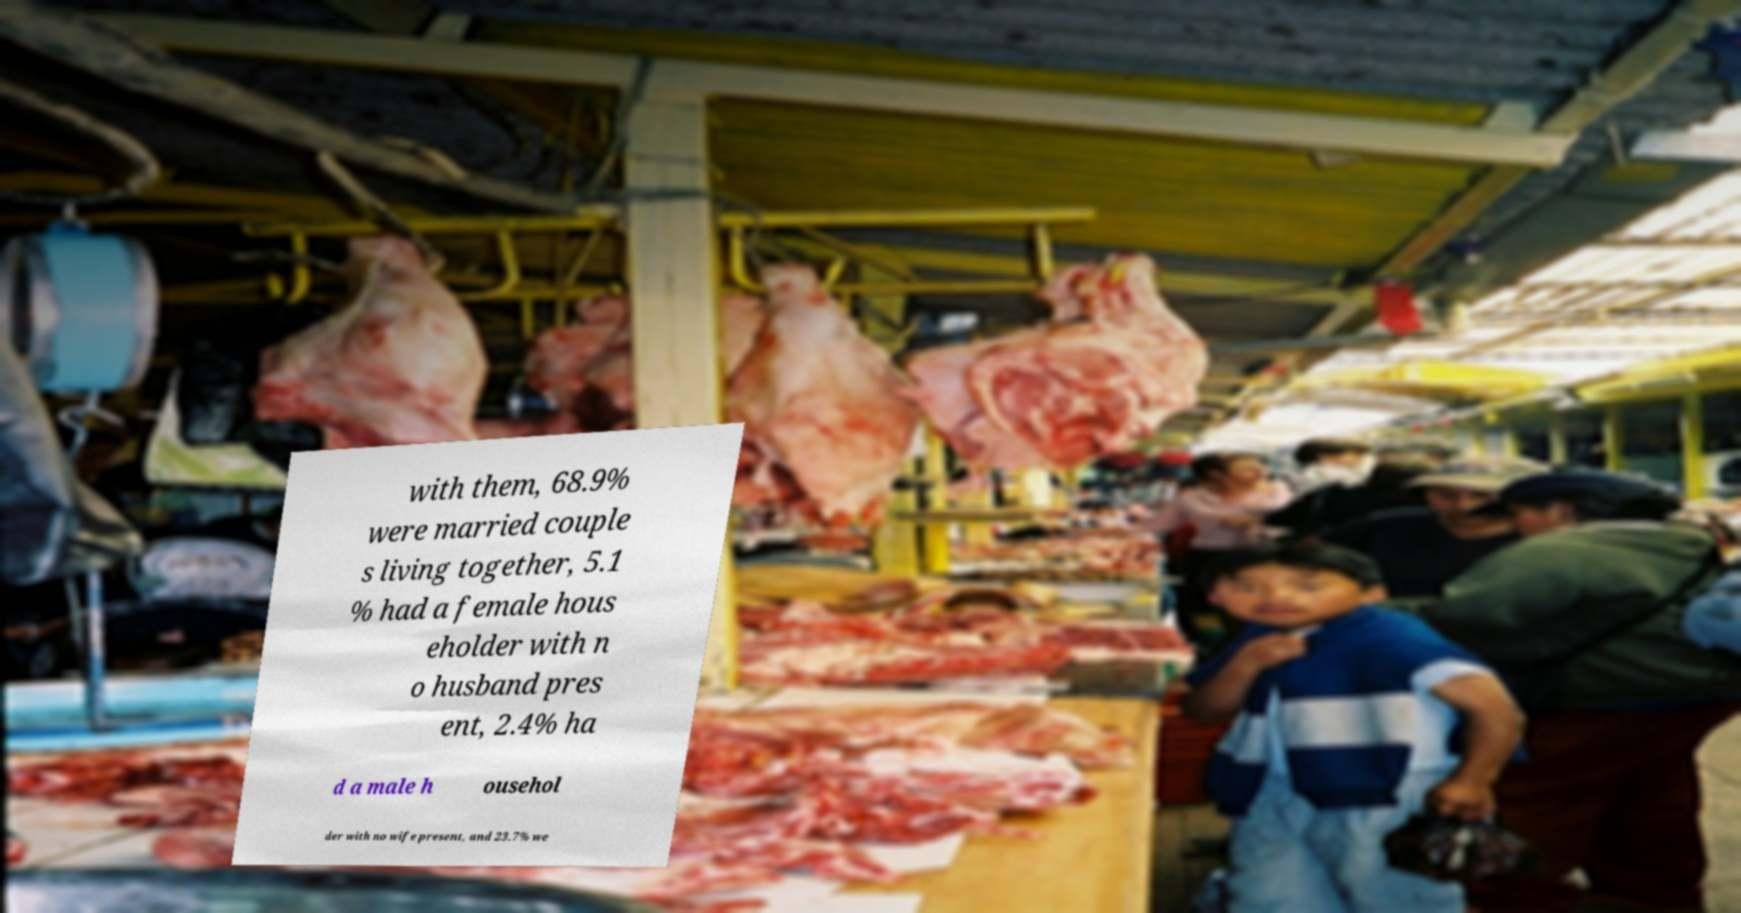Could you extract and type out the text from this image? with them, 68.9% were married couple s living together, 5.1 % had a female hous eholder with n o husband pres ent, 2.4% ha d a male h ousehol der with no wife present, and 23.7% we 